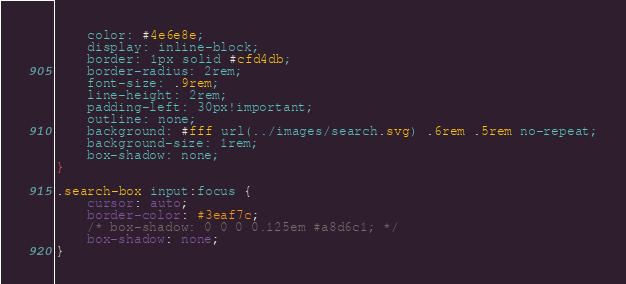Convert code to text. <code><loc_0><loc_0><loc_500><loc_500><_CSS_>    color: #4e6e8e;
    display: inline-block;
    border: 1px solid #cfd4db;
    border-radius: 2rem;
    font-size: .9rem;
    line-height: 2rem;
    padding-left: 30px!important;
    outline: none;
    background: #fff url(../images/search.svg) .6rem .5rem no-repeat;
    background-size: 1rem;
    box-shadow: none;
}

.search-box input:focus {
    cursor: auto;
    border-color: #3eaf7c;
    /* box-shadow: 0 0 0 0.125em #a8d6c1; */
    box-shadow: none;
}</code> 